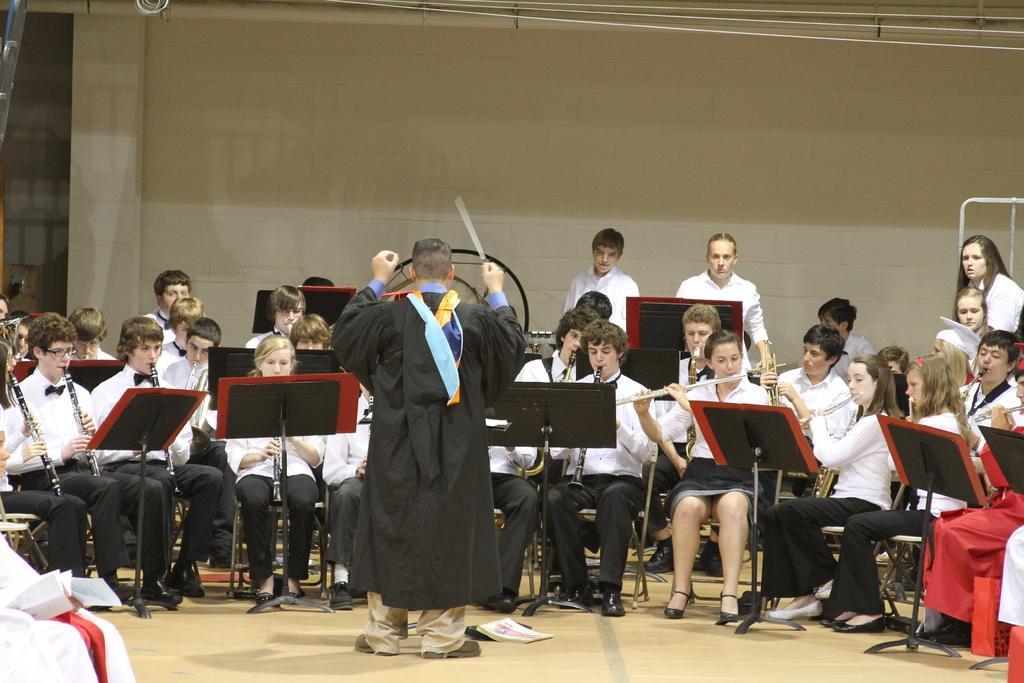In one or two sentences, can you explain what this image depicts? In this picture we can see a few people sitting on the chair and playing musical instruments. There are some rods, stand and a book is visible on the ground. We can see a person and an object on the left side. There are a few objects visible on top of the picture. 